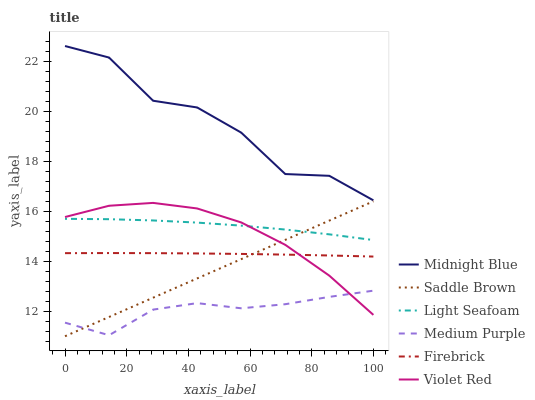Does Medium Purple have the minimum area under the curve?
Answer yes or no. Yes. Does Midnight Blue have the maximum area under the curve?
Answer yes or no. Yes. Does Firebrick have the minimum area under the curve?
Answer yes or no. No. Does Firebrick have the maximum area under the curve?
Answer yes or no. No. Is Saddle Brown the smoothest?
Answer yes or no. Yes. Is Midnight Blue the roughest?
Answer yes or no. Yes. Is Firebrick the smoothest?
Answer yes or no. No. Is Firebrick the roughest?
Answer yes or no. No. Does Saddle Brown have the lowest value?
Answer yes or no. Yes. Does Firebrick have the lowest value?
Answer yes or no. No. Does Midnight Blue have the highest value?
Answer yes or no. Yes. Does Firebrick have the highest value?
Answer yes or no. No. Is Medium Purple less than Firebrick?
Answer yes or no. Yes. Is Midnight Blue greater than Violet Red?
Answer yes or no. Yes. Does Saddle Brown intersect Violet Red?
Answer yes or no. Yes. Is Saddle Brown less than Violet Red?
Answer yes or no. No. Is Saddle Brown greater than Violet Red?
Answer yes or no. No. Does Medium Purple intersect Firebrick?
Answer yes or no. No. 